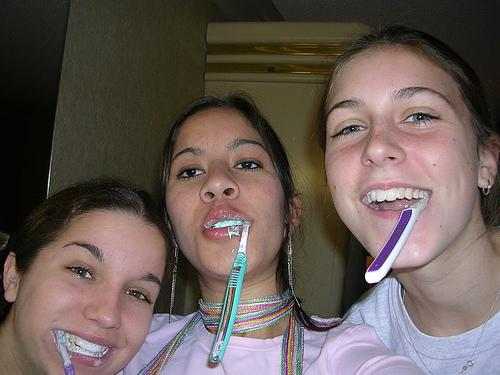What color is the toothbrush in the mouth of the woman in the center?

Choices:
A) purple
B) turquoise
C) red
D) pink turquoise 